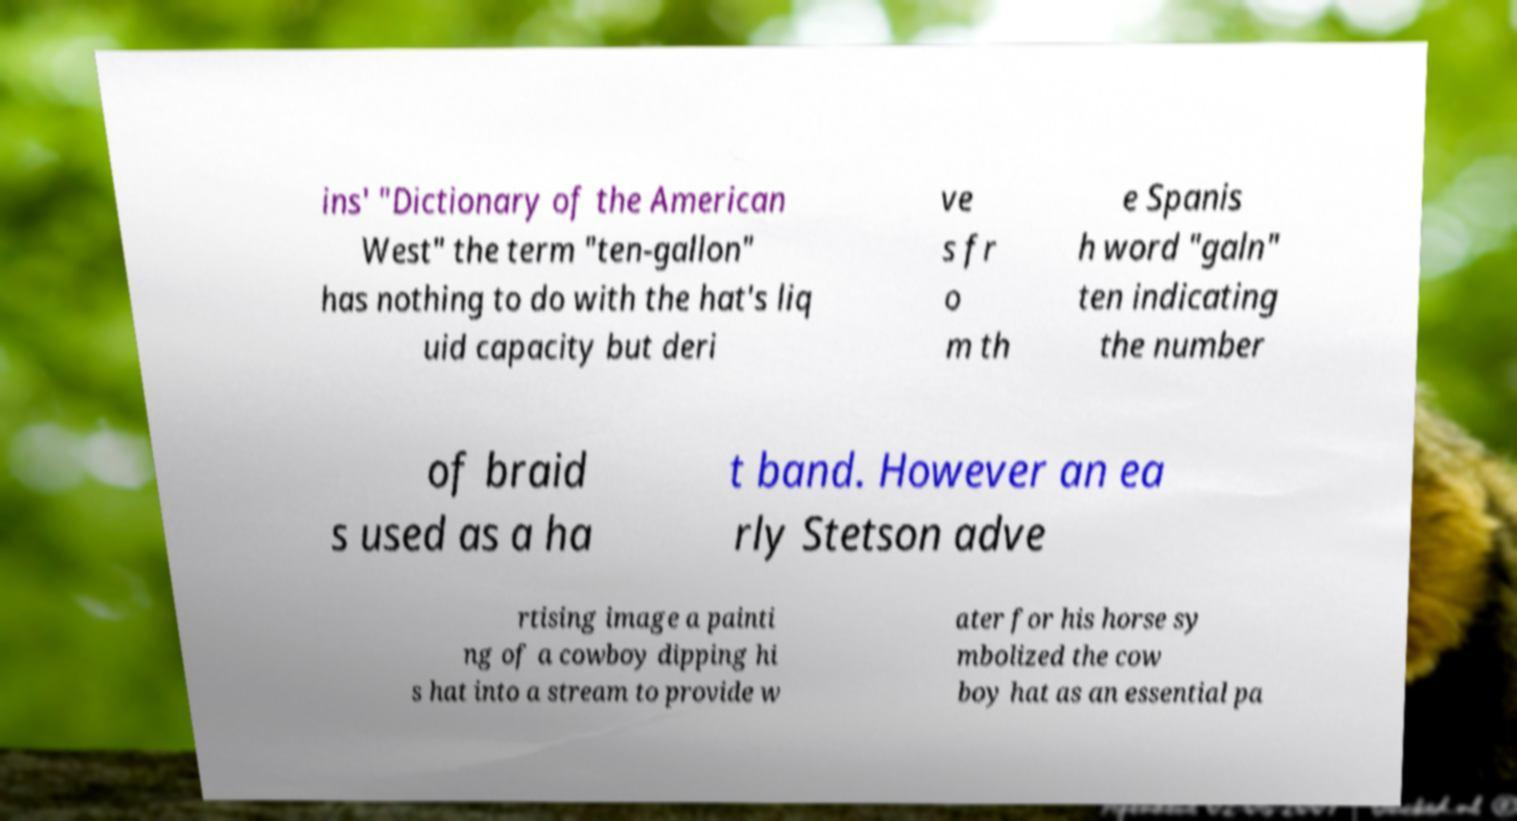Could you assist in decoding the text presented in this image and type it out clearly? ins' "Dictionary of the American West" the term "ten-gallon" has nothing to do with the hat's liq uid capacity but deri ve s fr o m th e Spanis h word "galn" ten indicating the number of braid s used as a ha t band. However an ea rly Stetson adve rtising image a painti ng of a cowboy dipping hi s hat into a stream to provide w ater for his horse sy mbolized the cow boy hat as an essential pa 